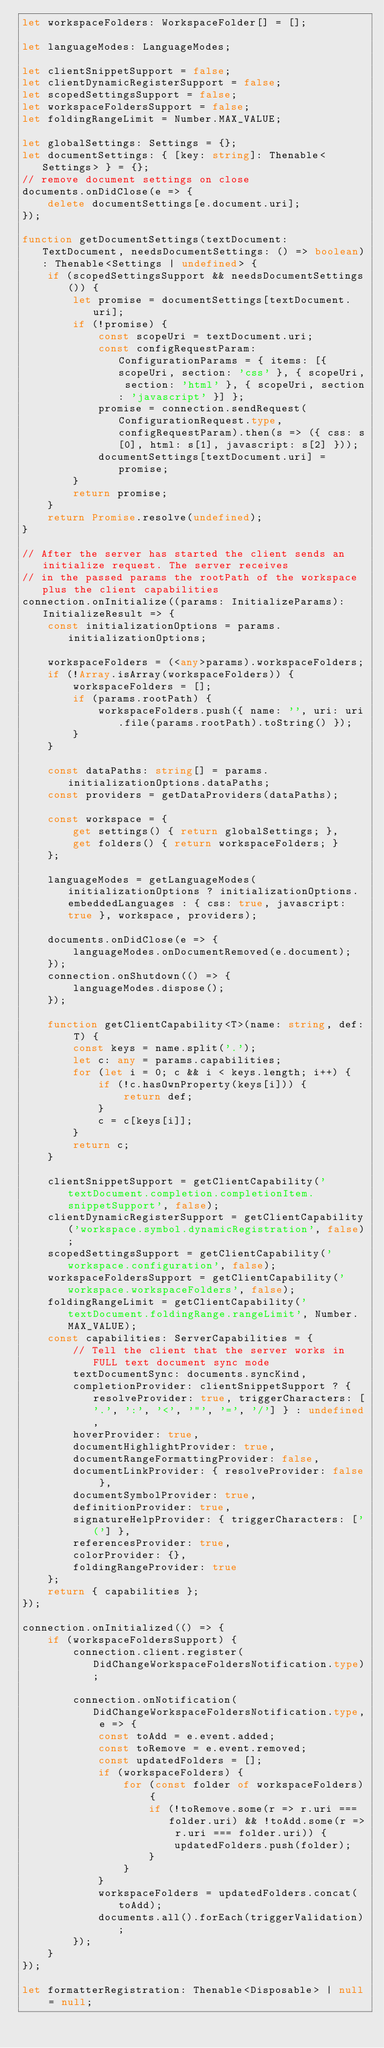Convert code to text. <code><loc_0><loc_0><loc_500><loc_500><_TypeScript_>let workspaceFolders: WorkspaceFolder[] = [];

let languageModes: LanguageModes;

let clientSnippetSupport = false;
let clientDynamicRegisterSupport = false;
let scopedSettingsSupport = false;
let workspaceFoldersSupport = false;
let foldingRangeLimit = Number.MAX_VALUE;

let globalSettings: Settings = {};
let documentSettings: { [key: string]: Thenable<Settings> } = {};
// remove document settings on close
documents.onDidClose(e => {
	delete documentSettings[e.document.uri];
});

function getDocumentSettings(textDocument: TextDocument, needsDocumentSettings: () => boolean): Thenable<Settings | undefined> {
	if (scopedSettingsSupport && needsDocumentSettings()) {
		let promise = documentSettings[textDocument.uri];
		if (!promise) {
			const scopeUri = textDocument.uri;
			const configRequestParam: ConfigurationParams = { items: [{ scopeUri, section: 'css' }, { scopeUri, section: 'html' }, { scopeUri, section: 'javascript' }] };
			promise = connection.sendRequest(ConfigurationRequest.type, configRequestParam).then(s => ({ css: s[0], html: s[1], javascript: s[2] }));
			documentSettings[textDocument.uri] = promise;
		}
		return promise;
	}
	return Promise.resolve(undefined);
}

// After the server has started the client sends an initialize request. The server receives
// in the passed params the rootPath of the workspace plus the client capabilities
connection.onInitialize((params: InitializeParams): InitializeResult => {
	const initializationOptions = params.initializationOptions;

	workspaceFolders = (<any>params).workspaceFolders;
	if (!Array.isArray(workspaceFolders)) {
		workspaceFolders = [];
		if (params.rootPath) {
			workspaceFolders.push({ name: '', uri: uri.file(params.rootPath).toString() });
		}
	}

	const dataPaths: string[] = params.initializationOptions.dataPaths;
	const providers = getDataProviders(dataPaths);

	const workspace = {
		get settings() { return globalSettings; },
		get folders() { return workspaceFolders; }
	};

	languageModes = getLanguageModes(initializationOptions ? initializationOptions.embeddedLanguages : { css: true, javascript: true }, workspace, providers);

	documents.onDidClose(e => {
		languageModes.onDocumentRemoved(e.document);
	});
	connection.onShutdown(() => {
		languageModes.dispose();
	});

	function getClientCapability<T>(name: string, def: T) {
		const keys = name.split('.');
		let c: any = params.capabilities;
		for (let i = 0; c && i < keys.length; i++) {
			if (!c.hasOwnProperty(keys[i])) {
				return def;
			}
			c = c[keys[i]];
		}
		return c;
	}

	clientSnippetSupport = getClientCapability('textDocument.completion.completionItem.snippetSupport', false);
	clientDynamicRegisterSupport = getClientCapability('workspace.symbol.dynamicRegistration', false);
	scopedSettingsSupport = getClientCapability('workspace.configuration', false);
	workspaceFoldersSupport = getClientCapability('workspace.workspaceFolders', false);
	foldingRangeLimit = getClientCapability('textDocument.foldingRange.rangeLimit', Number.MAX_VALUE);
	const capabilities: ServerCapabilities = {
		// Tell the client that the server works in FULL text document sync mode
		textDocumentSync: documents.syncKind,
		completionProvider: clientSnippetSupport ? { resolveProvider: true, triggerCharacters: ['.', ':', '<', '"', '=', '/'] } : undefined,
		hoverProvider: true,
		documentHighlightProvider: true,
		documentRangeFormattingProvider: false,
		documentLinkProvider: { resolveProvider: false },
		documentSymbolProvider: true,
		definitionProvider: true,
		signatureHelpProvider: { triggerCharacters: ['('] },
		referencesProvider: true,
		colorProvider: {},
		foldingRangeProvider: true
	};
	return { capabilities };
});

connection.onInitialized(() => {
	if (workspaceFoldersSupport) {
		connection.client.register(DidChangeWorkspaceFoldersNotification.type);

		connection.onNotification(DidChangeWorkspaceFoldersNotification.type, e => {
			const toAdd = e.event.added;
			const toRemove = e.event.removed;
			const updatedFolders = [];
			if (workspaceFolders) {
				for (const folder of workspaceFolders) {
					if (!toRemove.some(r => r.uri === folder.uri) && !toAdd.some(r => r.uri === folder.uri)) {
						updatedFolders.push(folder);
					}
				}
			}
			workspaceFolders = updatedFolders.concat(toAdd);
			documents.all().forEach(triggerValidation);
		});
	}
});

let formatterRegistration: Thenable<Disposable> | null = null;
</code> 